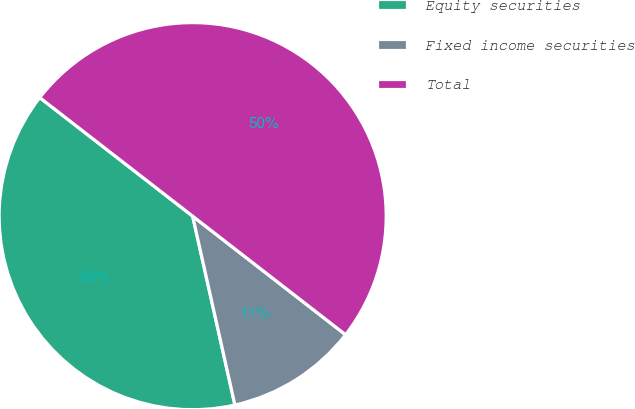Convert chart. <chart><loc_0><loc_0><loc_500><loc_500><pie_chart><fcel>Equity securities<fcel>Fixed income securities<fcel>Total<nl><fcel>39.0%<fcel>11.0%<fcel>50.0%<nl></chart> 